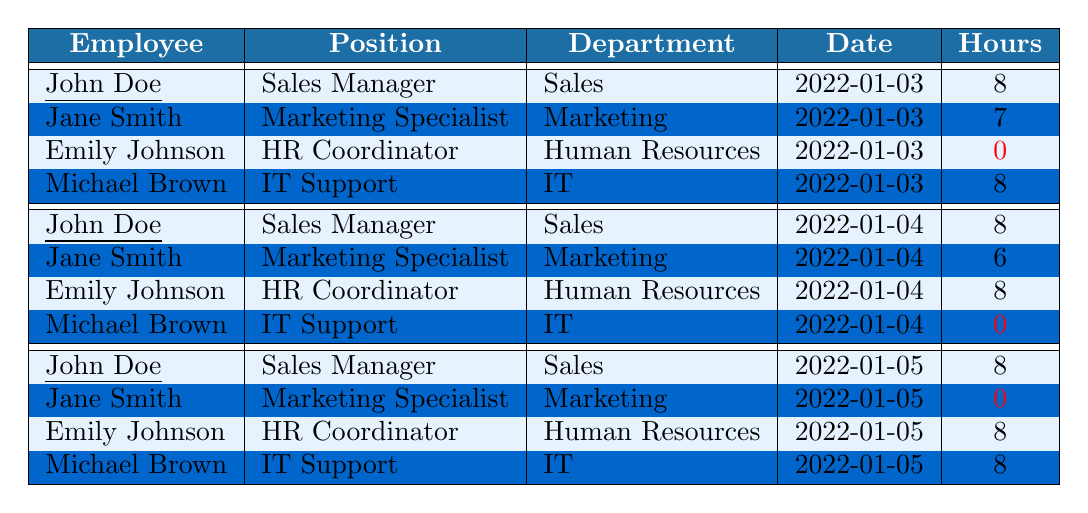What is the total number of hours worked by John Doe? John Doe has worked a total of 8 hours on January 3, 4, and 5. Adding these hours gives us 8 + 8 + 8 = 24.
Answer: 24 What was Jane Smith's attendance status on January 5? Jane Smith's status on January 5 is "Absent," as indicated in the table where her hours worked is shown as 0.
Answer: Absent How many employees were present on January 4? On January 4, the table shows John Doe, Emily Johnson as present, but Jane Smith and Michael Brown were absent, totaling 3 present employees (John, Emily, and Michael).
Answer: 3 What is the average hours worked by employees on January 3? The employees' hours worked on January 3 are 8 (John Doe) + 7 (Jane Smith) + 0 (Emily Johnson) + 8 (Michael Brown) = 23. There are 4 entries, so the average is 23/4 = 5.75.
Answer: 5.75 Did Michael Brown ever have a day of absence? Referring to the table, Michael Brown has his attendance marked as "Absent" on January 4, confirming he did have a day of absence.
Answer: Yes How many hours did Emily Johnson work in total? Emily worked 0 hours on January 3, 8 hours on January 4, and 8 hours on January 5. The total is 0 + 8 + 8 = 16 hours.
Answer: 16 On which date did Jane Smith work the least hours? Looking at the table, Jane Smith worked 7 hours on January 3 and 6 hours on January 4, but was absent on January 5 with 0 hours. Therefore, the date with the least hours is January 5.
Answer: January 5 Which employee worked the most hours on any single day? John Doe, Emily Johnson, and Michael Brown all worked 8 hours on multiple days, but 8 is the highest mentioned for any single day. Thus, the maximum is 8 hours.
Answer: 8 Is it true that no employee worked more than 8 hours in a day? Upon reviewing the table, every entry lists hours worked as 8 or less, confirming the statement is true.
Answer: True What was the combined total hours worked by all employees on January 5? The total hours worked on January 5 were 8 (John Doe) + 0 (Jane Smith) + 8 (Emily Johnson) + 8 (Michael Brown) = 24.
Answer: 24 